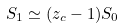Convert formula to latex. <formula><loc_0><loc_0><loc_500><loc_500>S _ { 1 } \simeq ( z _ { c } - 1 ) S _ { 0 }</formula> 